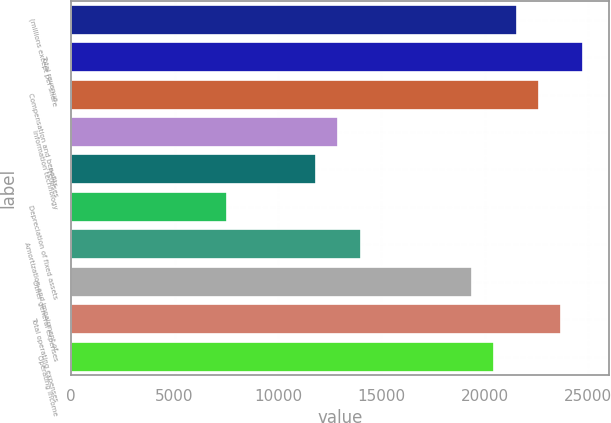Convert chart to OTSL. <chart><loc_0><loc_0><loc_500><loc_500><bar_chart><fcel>(millions except per share<fcel>Total revenue<fcel>Compensation and benefits<fcel>Information technology<fcel>Premises<fcel>Depreciation of fixed assets<fcel>Amortization and impairment of<fcel>Other general expenses<fcel>Total operating expenses<fcel>Operating income<nl><fcel>21539.7<fcel>24770.6<fcel>22616.7<fcel>12923.9<fcel>11847<fcel>7539.09<fcel>14000.9<fcel>19385.8<fcel>23693.6<fcel>20462.7<nl></chart> 